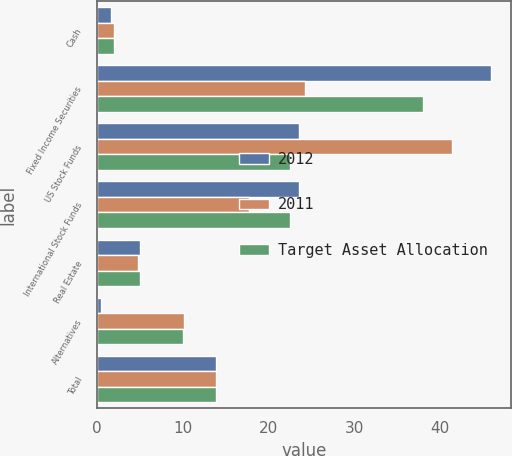Convert chart. <chart><loc_0><loc_0><loc_500><loc_500><stacked_bar_chart><ecel><fcel>Cash<fcel>Fixed Income Securities<fcel>US Stock Funds<fcel>International Stock Funds<fcel>Real Estate<fcel>Alternatives<fcel>Total<nl><fcel>2012<fcel>1.6<fcel>46<fcel>23.5<fcel>23.5<fcel>5<fcel>0.4<fcel>13.9<nl><fcel>2011<fcel>1.9<fcel>24.2<fcel>41.4<fcel>17.7<fcel>4.7<fcel>10.1<fcel>13.9<nl><fcel>Target Asset Allocation<fcel>2<fcel>38<fcel>22.5<fcel>22.5<fcel>5<fcel>10<fcel>13.9<nl></chart> 